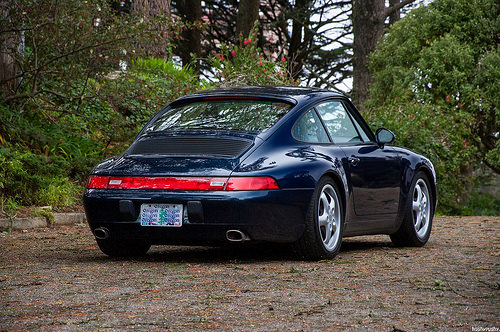<image>
Is the car on the ground? Yes. Looking at the image, I can see the car is positioned on top of the ground, with the ground providing support. 